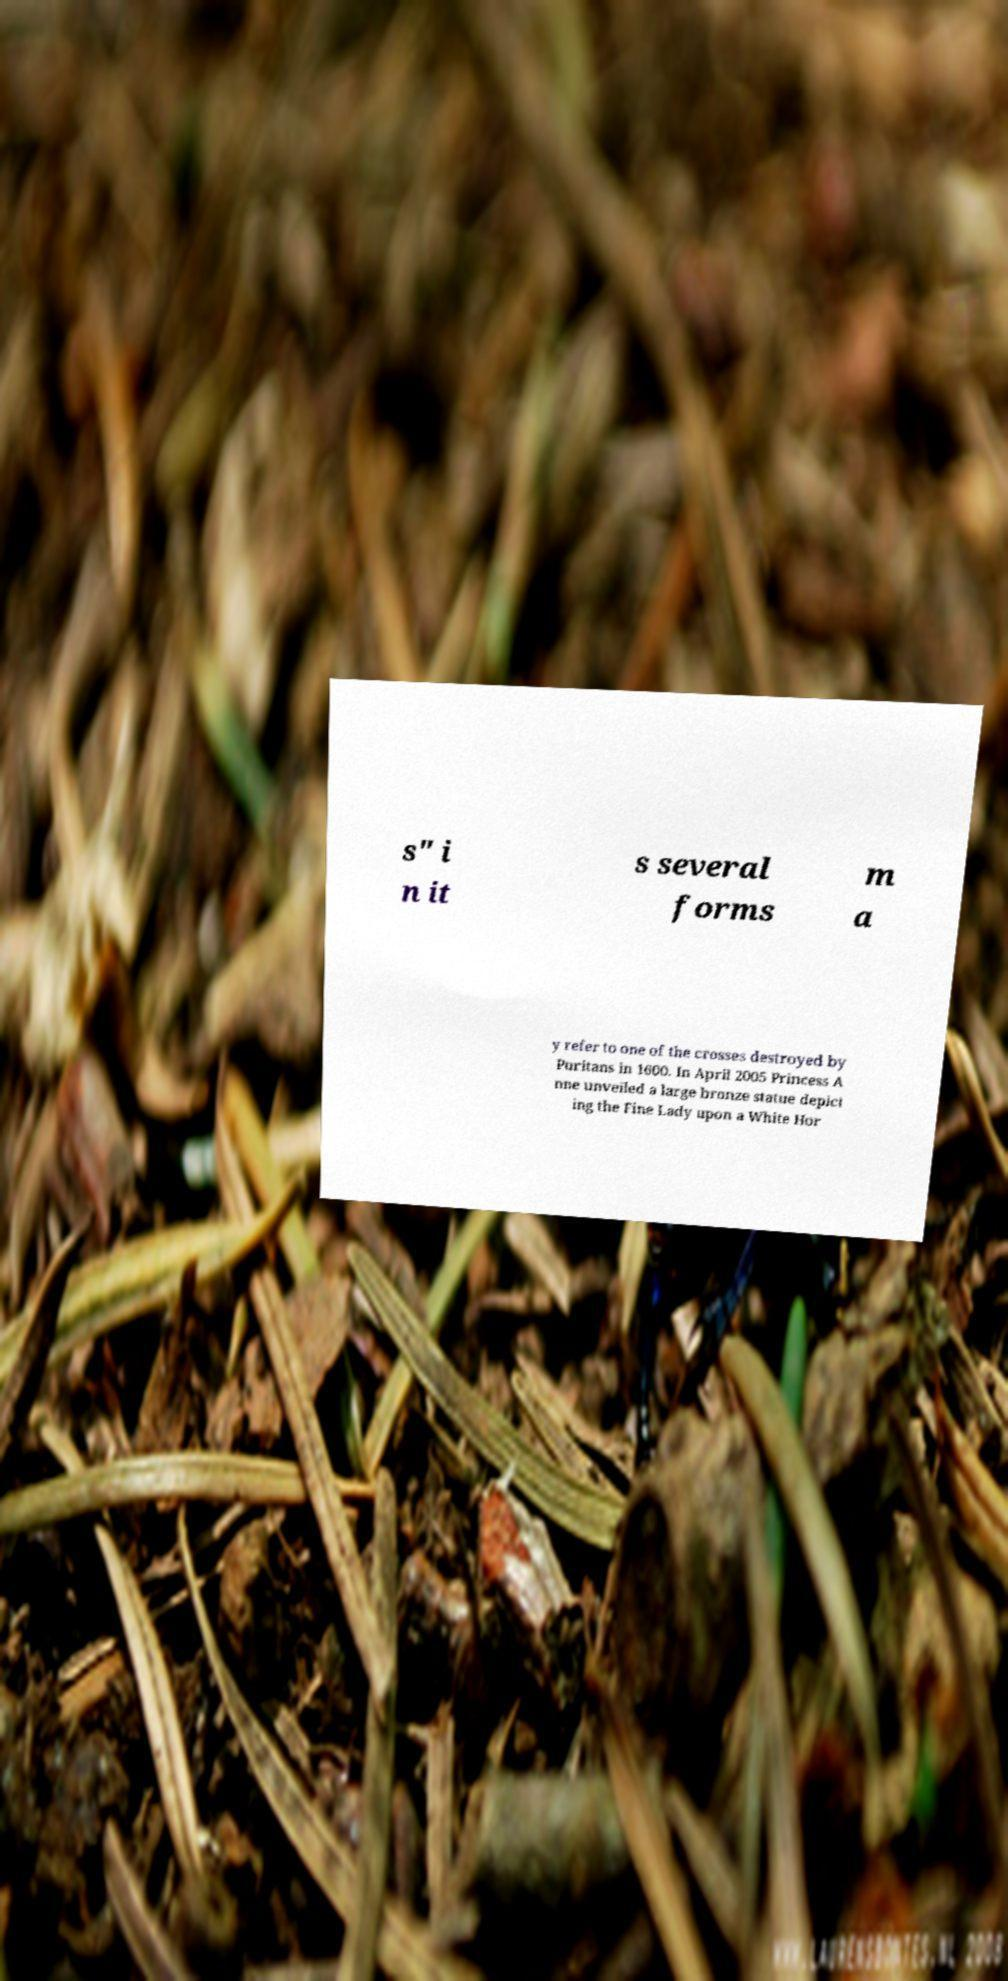Please identify and transcribe the text found in this image. s" i n it s several forms m a y refer to one of the crosses destroyed by Puritans in 1600. In April 2005 Princess A nne unveiled a large bronze statue depict ing the Fine Lady upon a White Hor 